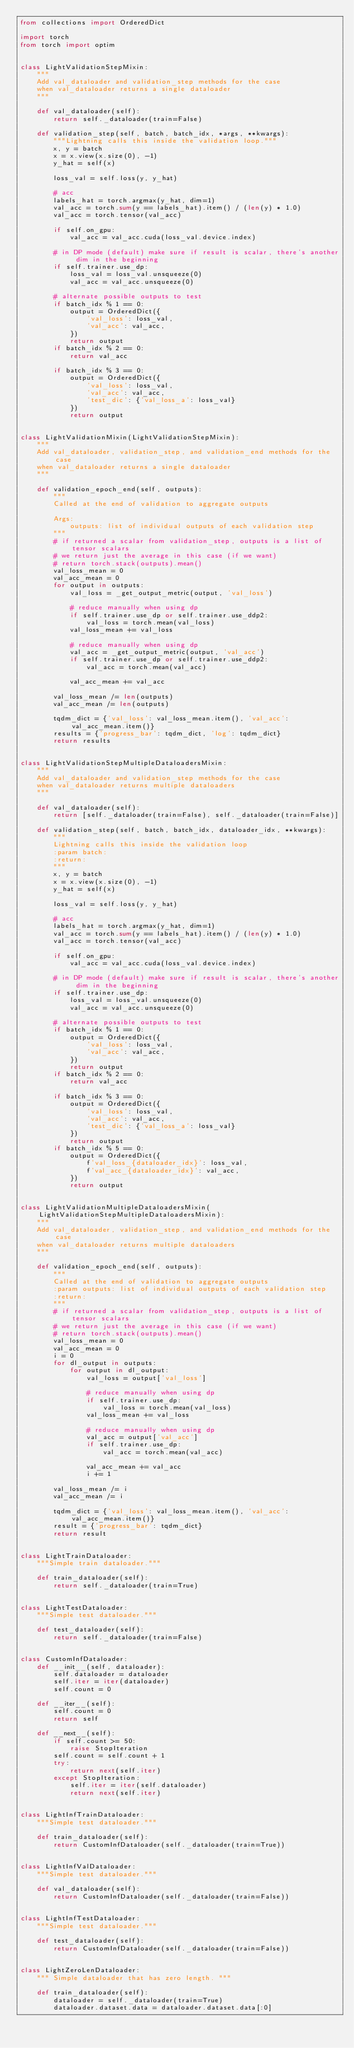<code> <loc_0><loc_0><loc_500><loc_500><_Python_>from collections import OrderedDict

import torch
from torch import optim


class LightValidationStepMixin:
    """
    Add val_dataloader and validation_step methods for the case
    when val_dataloader returns a single dataloader
    """

    def val_dataloader(self):
        return self._dataloader(train=False)

    def validation_step(self, batch, batch_idx, *args, **kwargs):
        """Lightning calls this inside the validation loop."""
        x, y = batch
        x = x.view(x.size(0), -1)
        y_hat = self(x)

        loss_val = self.loss(y, y_hat)

        # acc
        labels_hat = torch.argmax(y_hat, dim=1)
        val_acc = torch.sum(y == labels_hat).item() / (len(y) * 1.0)
        val_acc = torch.tensor(val_acc)

        if self.on_gpu:
            val_acc = val_acc.cuda(loss_val.device.index)

        # in DP mode (default) make sure if result is scalar, there's another dim in the beginning
        if self.trainer.use_dp:
            loss_val = loss_val.unsqueeze(0)
            val_acc = val_acc.unsqueeze(0)

        # alternate possible outputs to test
        if batch_idx % 1 == 0:
            output = OrderedDict({
                'val_loss': loss_val,
                'val_acc': val_acc,
            })
            return output
        if batch_idx % 2 == 0:
            return val_acc

        if batch_idx % 3 == 0:
            output = OrderedDict({
                'val_loss': loss_val,
                'val_acc': val_acc,
                'test_dic': {'val_loss_a': loss_val}
            })
            return output


class LightValidationMixin(LightValidationStepMixin):
    """
    Add val_dataloader, validation_step, and validation_end methods for the case
    when val_dataloader returns a single dataloader
    """

    def validation_epoch_end(self, outputs):
        """
        Called at the end of validation to aggregate outputs

        Args:
            outputs: list of individual outputs of each validation step
        """
        # if returned a scalar from validation_step, outputs is a list of tensor scalars
        # we return just the average in this case (if we want)
        # return torch.stack(outputs).mean()
        val_loss_mean = 0
        val_acc_mean = 0
        for output in outputs:
            val_loss = _get_output_metric(output, 'val_loss')

            # reduce manually when using dp
            if self.trainer.use_dp or self.trainer.use_ddp2:
                val_loss = torch.mean(val_loss)
            val_loss_mean += val_loss

            # reduce manually when using dp
            val_acc = _get_output_metric(output, 'val_acc')
            if self.trainer.use_dp or self.trainer.use_ddp2:
                val_acc = torch.mean(val_acc)

            val_acc_mean += val_acc

        val_loss_mean /= len(outputs)
        val_acc_mean /= len(outputs)

        tqdm_dict = {'val_loss': val_loss_mean.item(), 'val_acc': val_acc_mean.item()}
        results = {'progress_bar': tqdm_dict, 'log': tqdm_dict}
        return results


class LightValidationStepMultipleDataloadersMixin:
    """
    Add val_dataloader and validation_step methods for the case
    when val_dataloader returns multiple dataloaders
    """

    def val_dataloader(self):
        return [self._dataloader(train=False), self._dataloader(train=False)]

    def validation_step(self, batch, batch_idx, dataloader_idx, **kwargs):
        """
        Lightning calls this inside the validation loop
        :param batch:
        :return:
        """
        x, y = batch
        x = x.view(x.size(0), -1)
        y_hat = self(x)

        loss_val = self.loss(y, y_hat)

        # acc
        labels_hat = torch.argmax(y_hat, dim=1)
        val_acc = torch.sum(y == labels_hat).item() / (len(y) * 1.0)
        val_acc = torch.tensor(val_acc)

        if self.on_gpu:
            val_acc = val_acc.cuda(loss_val.device.index)

        # in DP mode (default) make sure if result is scalar, there's another dim in the beginning
        if self.trainer.use_dp:
            loss_val = loss_val.unsqueeze(0)
            val_acc = val_acc.unsqueeze(0)

        # alternate possible outputs to test
        if batch_idx % 1 == 0:
            output = OrderedDict({
                'val_loss': loss_val,
                'val_acc': val_acc,
            })
            return output
        if batch_idx % 2 == 0:
            return val_acc

        if batch_idx % 3 == 0:
            output = OrderedDict({
                'val_loss': loss_val,
                'val_acc': val_acc,
                'test_dic': {'val_loss_a': loss_val}
            })
            return output
        if batch_idx % 5 == 0:
            output = OrderedDict({
                f'val_loss_{dataloader_idx}': loss_val,
                f'val_acc_{dataloader_idx}': val_acc,
            })
            return output


class LightValidationMultipleDataloadersMixin(LightValidationStepMultipleDataloadersMixin):
    """
    Add val_dataloader, validation_step, and validation_end methods for the case
    when val_dataloader returns multiple dataloaders
    """

    def validation_epoch_end(self, outputs):
        """
        Called at the end of validation to aggregate outputs
        :param outputs: list of individual outputs of each validation step
        :return:
        """
        # if returned a scalar from validation_step, outputs is a list of tensor scalars
        # we return just the average in this case (if we want)
        # return torch.stack(outputs).mean()
        val_loss_mean = 0
        val_acc_mean = 0
        i = 0
        for dl_output in outputs:
            for output in dl_output:
                val_loss = output['val_loss']

                # reduce manually when using dp
                if self.trainer.use_dp:
                    val_loss = torch.mean(val_loss)
                val_loss_mean += val_loss

                # reduce manually when using dp
                val_acc = output['val_acc']
                if self.trainer.use_dp:
                    val_acc = torch.mean(val_acc)

                val_acc_mean += val_acc
                i += 1

        val_loss_mean /= i
        val_acc_mean /= i

        tqdm_dict = {'val_loss': val_loss_mean.item(), 'val_acc': val_acc_mean.item()}
        result = {'progress_bar': tqdm_dict}
        return result


class LightTrainDataloader:
    """Simple train dataloader."""

    def train_dataloader(self):
        return self._dataloader(train=True)


class LightTestDataloader:
    """Simple test dataloader."""

    def test_dataloader(self):
        return self._dataloader(train=False)


class CustomInfDataloader:
    def __init__(self, dataloader):
        self.dataloader = dataloader
        self.iter = iter(dataloader)
        self.count = 0

    def __iter__(self):
        self.count = 0
        return self

    def __next__(self):
        if self.count >= 50:
            raise StopIteration
        self.count = self.count + 1
        try:
            return next(self.iter)
        except StopIteration:
            self.iter = iter(self.dataloader)
            return next(self.iter)


class LightInfTrainDataloader:
    """Simple test dataloader."""

    def train_dataloader(self):
        return CustomInfDataloader(self._dataloader(train=True))


class LightInfValDataloader:
    """Simple test dataloader."""

    def val_dataloader(self):
        return CustomInfDataloader(self._dataloader(train=False))


class LightInfTestDataloader:
    """Simple test dataloader."""

    def test_dataloader(self):
        return CustomInfDataloader(self._dataloader(train=False))


class LightZeroLenDataloader:
    """ Simple dataloader that has zero length. """

    def train_dataloader(self):
        dataloader = self._dataloader(train=True)
        dataloader.dataset.data = dataloader.dataset.data[:0]</code> 